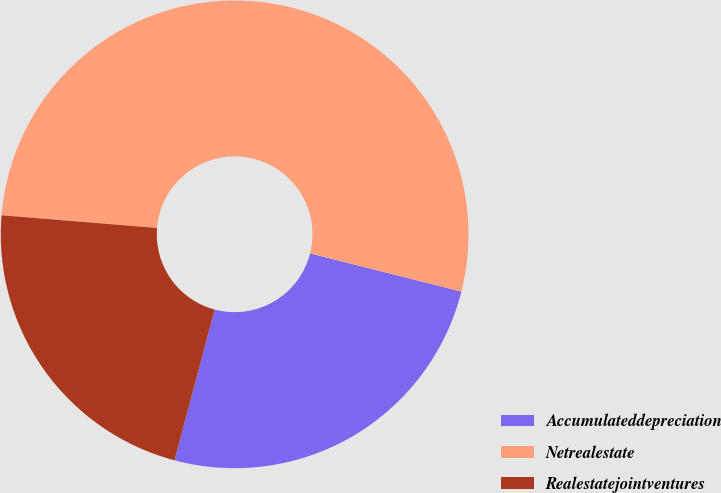Convert chart. <chart><loc_0><loc_0><loc_500><loc_500><pie_chart><fcel>Accumulateddepreciation<fcel>Netrealestate<fcel>Realestatejointventures<nl><fcel>25.2%<fcel>52.64%<fcel>22.16%<nl></chart> 